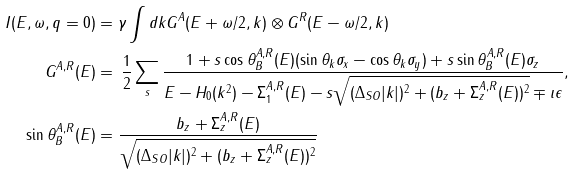<formula> <loc_0><loc_0><loc_500><loc_500>I ( E , \omega , q = 0 ) & = \gamma \int { d k } G ^ { A } ( E + \omega / 2 , k ) \otimes G ^ { R } ( E - \omega / 2 , k ) \\ G ^ { A , R } ( E ) & = \, \frac { 1 } { 2 } \sum _ { s } \frac { 1 + s \cos \theta ^ { A , R } _ { B } ( E ) ( \sin \theta _ { k } \sigma _ { x } - \cos \theta _ { k } \sigma _ { y } ) + s \sin \theta ^ { A , R } _ { B } ( E ) \sigma _ { z } } { E - H _ { 0 } ( k ^ { 2 } ) - \Sigma _ { 1 } ^ { A , R } ( E ) - s \sqrt { ( \Delta _ { S O } | k | ) ^ { 2 } + ( b _ { z } + \Sigma _ { z } ^ { A , R } ( E ) ) ^ { 2 } } \mp \imath \epsilon } , \\ \sin \theta _ { B } ^ { A , R } ( E ) & = \frac { b _ { z } + \Sigma _ { z } ^ { A , R } ( E ) } { \sqrt { ( \Delta _ { S O } | k | ) ^ { 2 } + ( b _ { z } + \Sigma _ { z } ^ { A , R } ( E ) ) ^ { 2 } } } \\</formula> 